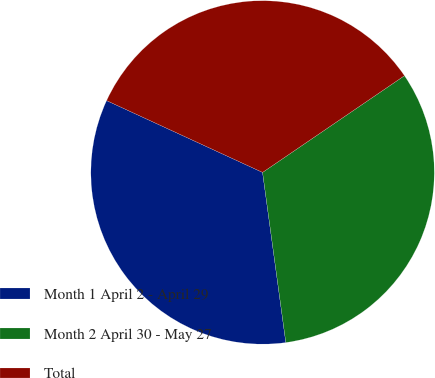<chart> <loc_0><loc_0><loc_500><loc_500><pie_chart><fcel>Month 1 April 2 - April 29<fcel>Month 2 April 30 - May 27<fcel>Total<nl><fcel>34.03%<fcel>32.36%<fcel>33.61%<nl></chart> 